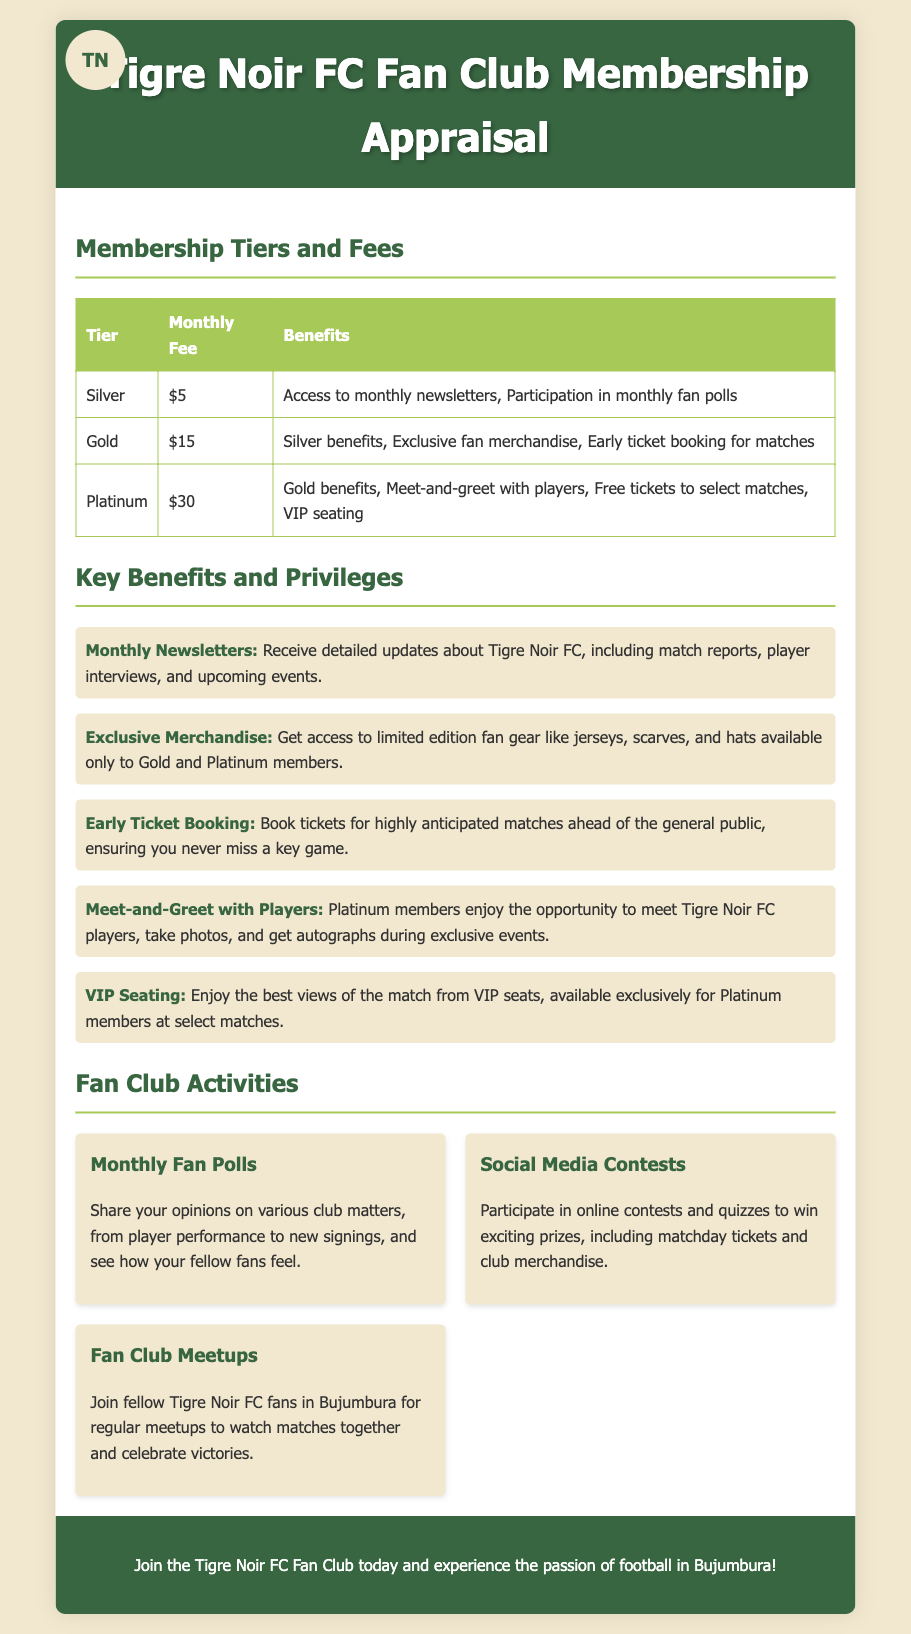What is the monthly fee for the Gold tier? The document states that the Gold tier has a monthly fee of $15.
Answer: $15 What benefit do Platinum members receive that Gold members do not? According to the document, Platinum members have access to benefits like meet-and-greet with players and VIP seating, which are not available to Gold members.
Answer: Meet-and-greet with players, VIP seating How many activities are mentioned in the Fan Club Activities section? The document lists three activities that are part of the Fan Club Activities section.
Answer: 3 What privilege allows fans to book tickets ahead of the general public? The document highlights Early Ticket Booking as a privilege that enables fans to book tickets before the general public.
Answer: Early Ticket Booking What type of merchandise is available only to Gold and Platinum members? The document specifies that Exclusive Merchandise is available to Gold and Platinum members.
Answer: Exclusive Merchandise 